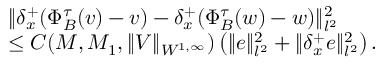<formula> <loc_0><loc_0><loc_500><loc_500>\begin{array} { r l } & { \| { \delta _ { x } ^ { + } } ( \Phi _ { B } ^ { \tau } ( v ) - v ) - { \delta _ { x } ^ { + } } ( \Phi _ { B } ^ { \tau } ( w ) - w ) \| _ { l ^ { 2 } } ^ { 2 } } \\ & { \leq C ( M , M _ { 1 } , \| V \| _ { W ^ { 1 , \infty } } ) \left ( \| e \| _ { l ^ { 2 } } ^ { 2 } + \| { \delta _ { x } ^ { + } } e \| _ { l ^ { 2 } } ^ { 2 } \right ) . } \end{array}</formula> 